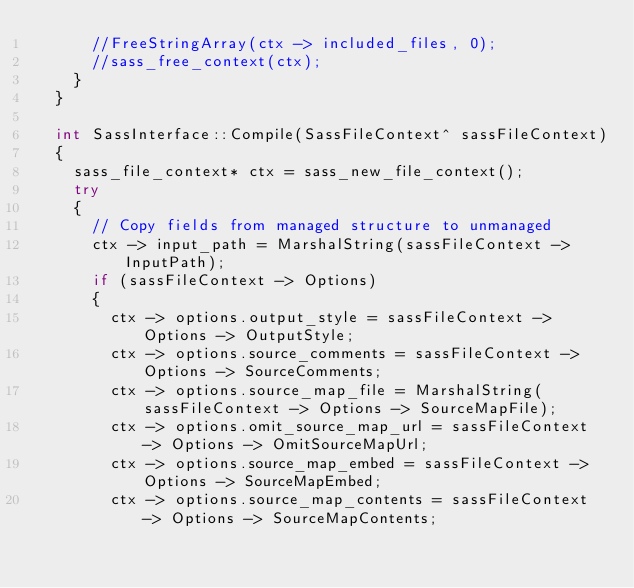Convert code to text. <code><loc_0><loc_0><loc_500><loc_500><_C++_>			//FreeStringArray(ctx -> included_files, 0);
			//sass_free_context(ctx);
		}
	}

	int SassInterface::Compile(SassFileContext^ sassFileContext)
	{
		sass_file_context* ctx = sass_new_file_context();
		try
		{
			// Copy fields from managed structure to unmanaged
			ctx -> input_path = MarshalString(sassFileContext -> InputPath);
			if (sassFileContext -> Options)
			{
				ctx -> options.output_style = sassFileContext -> Options -> OutputStyle;
				ctx -> options.source_comments = sassFileContext -> Options -> SourceComments;
				ctx -> options.source_map_file = MarshalString(sassFileContext -> Options -> SourceMapFile);
				ctx -> options.omit_source_map_url = sassFileContext -> Options -> OmitSourceMapUrl;
				ctx -> options.source_map_embed = sassFileContext -> Options -> SourceMapEmbed;
				ctx -> options.source_map_contents = sassFileContext -> Options -> SourceMapContents;</code> 